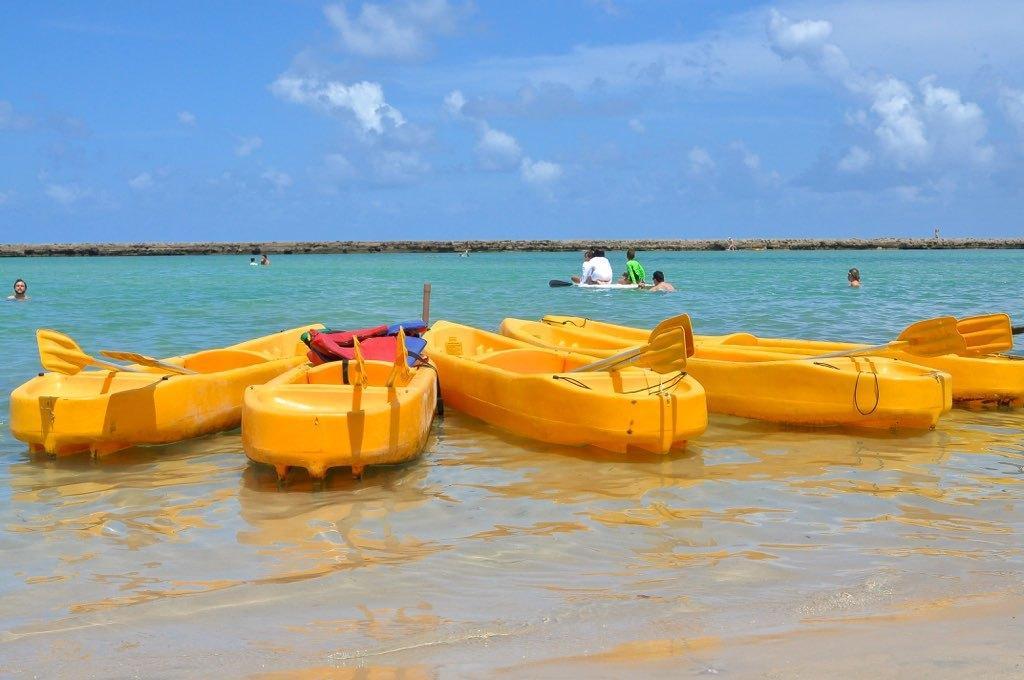Could you give a brief overview of what you see in this image? In this image I can see few boats on the water and the boats are in yellow color. Background I can see few people sitting on the water surface and the sky is in blue and white color. 